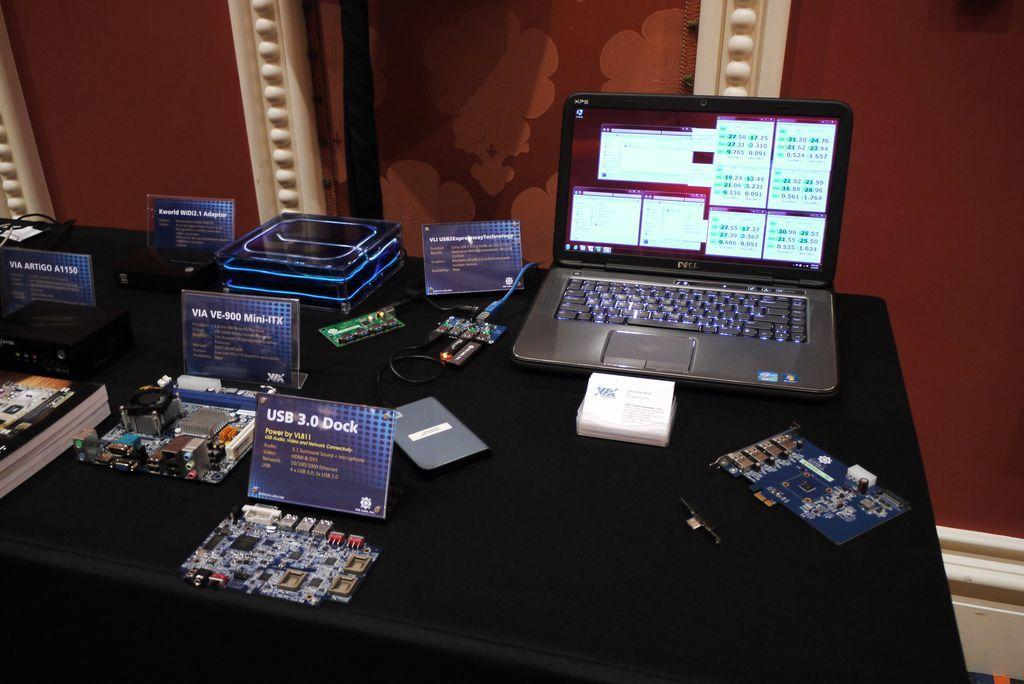<image>
Provide a brief description of the given image. A laptop computer sitting on table by a sign that says USB 3.0 Dock. 